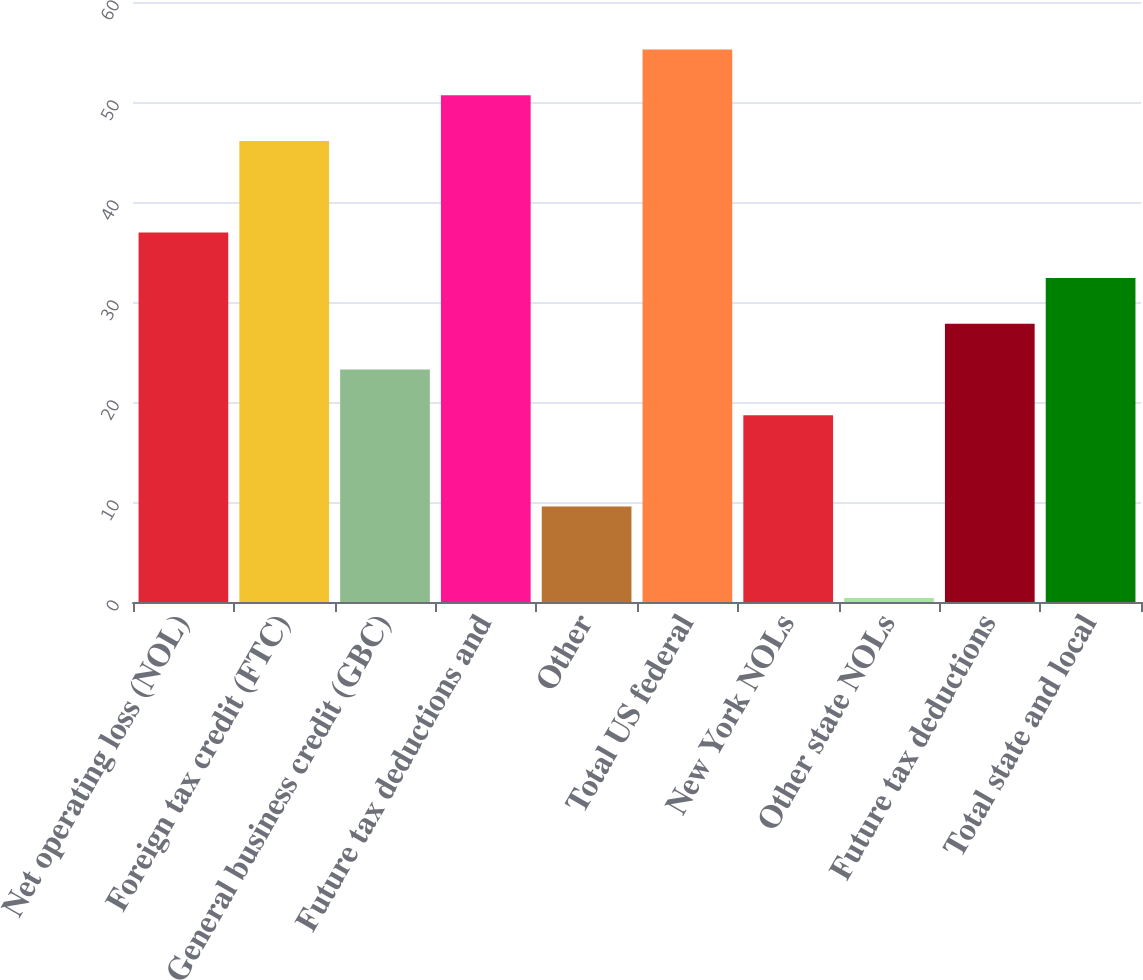<chart> <loc_0><loc_0><loc_500><loc_500><bar_chart><fcel>Net operating loss (NOL)<fcel>Foreign tax credit (FTC)<fcel>General business credit (GBC)<fcel>Future tax deductions and<fcel>Other<fcel>Total US federal<fcel>New York NOLs<fcel>Other state NOLs<fcel>Future tax deductions<fcel>Total state and local<nl><fcel>36.96<fcel>46.1<fcel>23.25<fcel>50.67<fcel>9.54<fcel>55.24<fcel>18.68<fcel>0.4<fcel>27.82<fcel>32.39<nl></chart> 